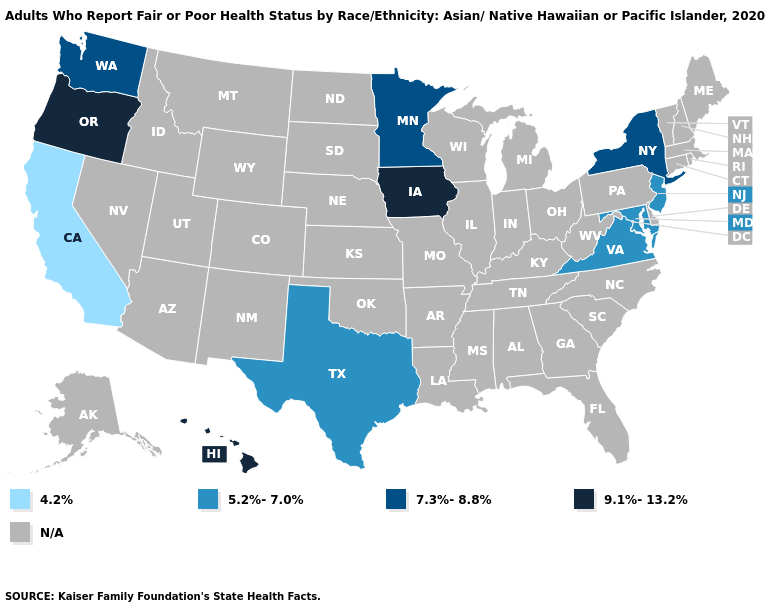Does Maryland have the highest value in the USA?
Keep it brief. No. What is the value of Massachusetts?
Concise answer only. N/A. Among the states that border Kentucky , which have the highest value?
Be succinct. Virginia. Does the first symbol in the legend represent the smallest category?
Quick response, please. Yes. Which states have the highest value in the USA?
Quick response, please. Hawaii, Iowa, Oregon. What is the highest value in the West ?
Give a very brief answer. 9.1%-13.2%. What is the value of South Carolina?
Short answer required. N/A. What is the value of Massachusetts?
Short answer required. N/A. What is the highest value in the West ?
Answer briefly. 9.1%-13.2%. Which states have the lowest value in the USA?
Write a very short answer. California. What is the lowest value in states that border North Dakota?
Quick response, please. 7.3%-8.8%. What is the highest value in states that border Louisiana?
Write a very short answer. 5.2%-7.0%. 